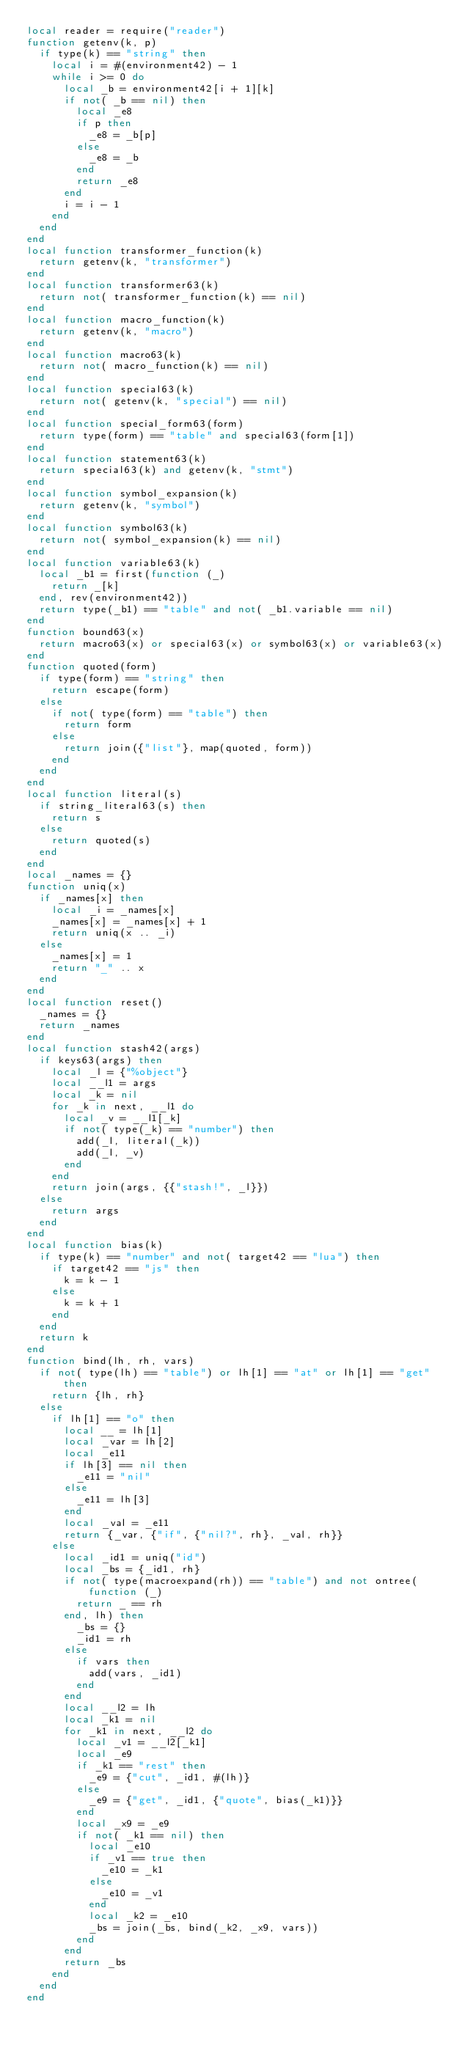Convert code to text. <code><loc_0><loc_0><loc_500><loc_500><_Lua_>local reader = require("reader")
function getenv(k, p)
  if type(k) == "string" then
    local i = #(environment42) - 1
    while i >= 0 do
      local _b = environment42[i + 1][k]
      if not( _b == nil) then
        local _e8
        if p then
          _e8 = _b[p]
        else
          _e8 = _b
        end
        return _e8
      end
      i = i - 1
    end
  end
end
local function transformer_function(k)
  return getenv(k, "transformer")
end
local function transformer63(k)
  return not( transformer_function(k) == nil)
end
local function macro_function(k)
  return getenv(k, "macro")
end
local function macro63(k)
  return not( macro_function(k) == nil)
end
local function special63(k)
  return not( getenv(k, "special") == nil)
end
local function special_form63(form)
  return type(form) == "table" and special63(form[1])
end
local function statement63(k)
  return special63(k) and getenv(k, "stmt")
end
local function symbol_expansion(k)
  return getenv(k, "symbol")
end
local function symbol63(k)
  return not( symbol_expansion(k) == nil)
end
local function variable63(k)
  local _b1 = first(function (_)
    return _[k]
  end, rev(environment42))
  return type(_b1) == "table" and not( _b1.variable == nil)
end
function bound63(x)
  return macro63(x) or special63(x) or symbol63(x) or variable63(x)
end
function quoted(form)
  if type(form) == "string" then
    return escape(form)
  else
    if not( type(form) == "table") then
      return form
    else
      return join({"list"}, map(quoted, form))
    end
  end
end
local function literal(s)
  if string_literal63(s) then
    return s
  else
    return quoted(s)
  end
end
local _names = {}
function uniq(x)
  if _names[x] then
    local _i = _names[x]
    _names[x] = _names[x] + 1
    return uniq(x .. _i)
  else
    _names[x] = 1
    return "_" .. x
  end
end
local function reset()
  _names = {}
  return _names
end
local function stash42(args)
  if keys63(args) then
    local _l = {"%object"}
    local __l1 = args
    local _k = nil
    for _k in next, __l1 do
      local _v = __l1[_k]
      if not( type(_k) == "number") then
        add(_l, literal(_k))
        add(_l, _v)
      end
    end
    return join(args, {{"stash!", _l}})
  else
    return args
  end
end
local function bias(k)
  if type(k) == "number" and not( target42 == "lua") then
    if target42 == "js" then
      k = k - 1
    else
      k = k + 1
    end
  end
  return k
end
function bind(lh, rh, vars)
  if not( type(lh) == "table") or lh[1] == "at" or lh[1] == "get" then
    return {lh, rh}
  else
    if lh[1] == "o" then
      local __ = lh[1]
      local _var = lh[2]
      local _e11
      if lh[3] == nil then
        _e11 = "nil"
      else
        _e11 = lh[3]
      end
      local _val = _e11
      return {_var, {"if", {"nil?", rh}, _val, rh}}
    else
      local _id1 = uniq("id")
      local _bs = {_id1, rh}
      if not( type(macroexpand(rh)) == "table") and not ontree(function (_)
        return _ == rh
      end, lh) then
        _bs = {}
        _id1 = rh
      else
        if vars then
          add(vars, _id1)
        end
      end
      local __l2 = lh
      local _k1 = nil
      for _k1 in next, __l2 do
        local _v1 = __l2[_k1]
        local _e9
        if _k1 == "rest" then
          _e9 = {"cut", _id1, #(lh)}
        else
          _e9 = {"get", _id1, {"quote", bias(_k1)}}
        end
        local _x9 = _e9
        if not( _k1 == nil) then
          local _e10
          if _v1 == true then
            _e10 = _k1
          else
            _e10 = _v1
          end
          local _k2 = _e10
          _bs = join(_bs, bind(_k2, _x9, vars))
        end
      end
      return _bs
    end
  end
end</code> 